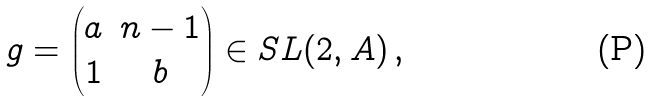<formula> <loc_0><loc_0><loc_500><loc_500>g = \begin{pmatrix} a & n - 1 \\ 1 & b \end{pmatrix} \in S L ( 2 , A ) \, ,</formula> 